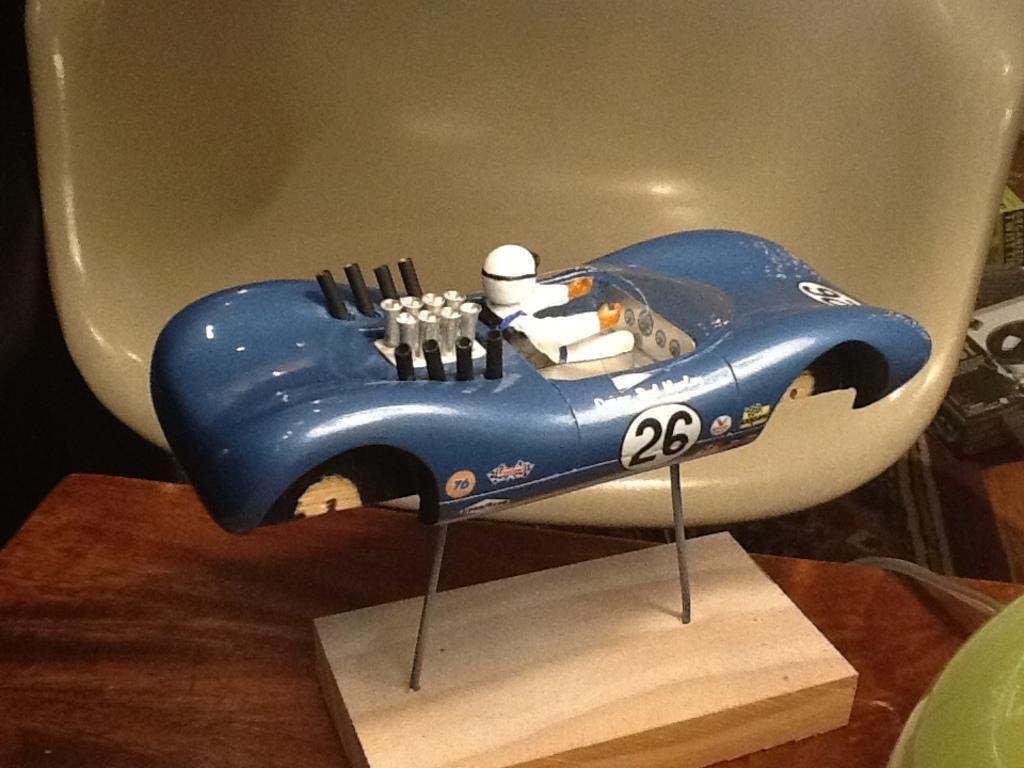What is the main subject on the platform in the image? There is an object on a platform in the image, but the specific object is not mentioned. Can you describe anything in the background of the image? Yes, there is a wooden object and some unspecified objects in the background of the image. How many birds can be seen flying in the image? There are no birds visible in the image. What type of trip is being taken by the object on the platform? The image does not provide any information about a trip or the object's purpose, so we cannot answer this question. 